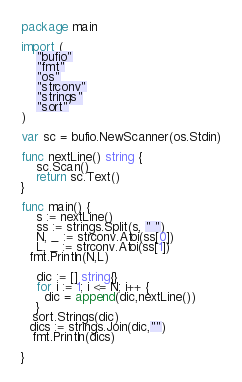Convert code to text. <code><loc_0><loc_0><loc_500><loc_500><_Go_>package main

import (
    "bufio"
    "fmt"
    "os"
  	"strconv"
  	"strings"
  	"sort"
)

var sc = bufio.NewScanner(os.Stdin)

func nextLine() string {
    sc.Scan()
    return sc.Text()
}

func main() {
    s := nextLine()
  	ss := strings.Split(s, " ")
  	N, _ := strconv.Atoi(ss[0])
  	L, _ := strconv.Atoi(ss[1])
  fmt.Println(N,L)
  
    dic := [] string{}
    for i := 1; i <= N; i++ {    
      dic = append(dic,nextLine())
    }
   sort.Strings(dic)
  dics := strings.Join(dic,"")
   fmt.Println(dics)
  
}</code> 